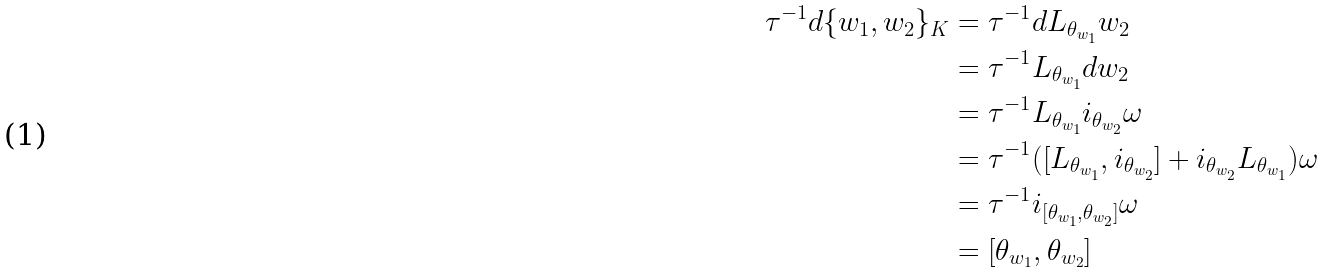<formula> <loc_0><loc_0><loc_500><loc_500>\tau ^ { - 1 } d \{ w _ { 1 } , w _ { 2 } \} _ { K } & = \tau ^ { - 1 } d L _ { \theta _ { w _ { 1 } } } w _ { 2 } \\ & = \tau ^ { - 1 } L _ { \theta _ { w _ { 1 } } } d w _ { 2 } \\ & = \tau ^ { - 1 } L _ { \theta _ { w _ { 1 } } } i _ { \theta _ { w _ { 2 } } } \omega \\ & = \tau ^ { - 1 } ( [ L _ { \theta _ { w _ { 1 } } } , i _ { \theta _ { w _ { 2 } } } ] + i _ { \theta _ { w _ { 2 } } } L _ { \theta _ { w _ { 1 } } } ) \omega \\ & = \tau ^ { - 1 } i _ { [ { \theta _ { w _ { 1 } } } , { \theta _ { w _ { 2 } } } ] } \omega \\ & = [ { \theta _ { w _ { 1 } } } , { \theta _ { w _ { 2 } } } ]</formula> 